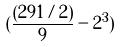<formula> <loc_0><loc_0><loc_500><loc_500>( \frac { ( 2 9 1 / 2 ) } { 9 } - 2 ^ { 3 } )</formula> 